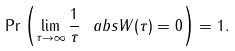<formula> <loc_0><loc_0><loc_500><loc_500>\Pr \left ( \lim _ { \tau \to \infty } \frac { 1 } { \tau } \ a b s { W ( \tau ) } = 0 \right ) = 1 .</formula> 